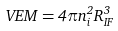Convert formula to latex. <formula><loc_0><loc_0><loc_500><loc_500>V E M = 4 \pi n _ { i } ^ { 2 } R _ { I F } ^ { 3 }</formula> 